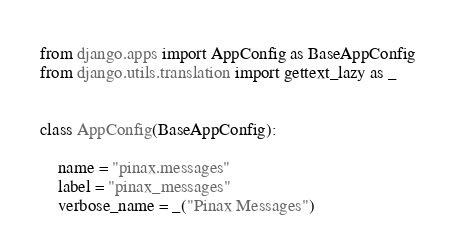Convert code to text. <code><loc_0><loc_0><loc_500><loc_500><_Python_>from django.apps import AppConfig as BaseAppConfig
from django.utils.translation import gettext_lazy as _


class AppConfig(BaseAppConfig):

    name = "pinax.messages"
    label = "pinax_messages"
    verbose_name = _("Pinax Messages")
</code> 